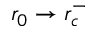Convert formula to latex. <formula><loc_0><loc_0><loc_500><loc_500>r _ { 0 } \rightarrow r _ { c } ^ { - }</formula> 